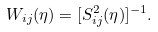Convert formula to latex. <formula><loc_0><loc_0><loc_500><loc_500>W _ { i j } ( \eta ) = [ S ^ { 2 } _ { i j } ( \eta ) ] ^ { - 1 } .</formula> 